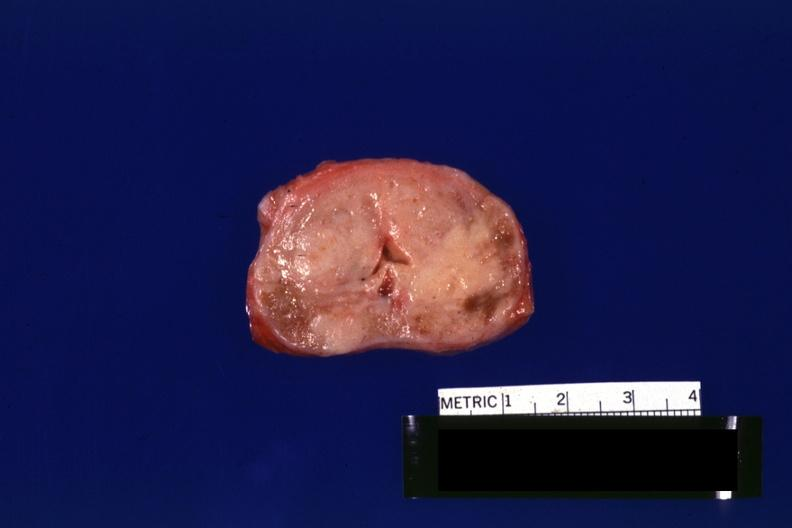what is not enlarged?
Answer the question using a single word or phrase. Neoplasm gland 